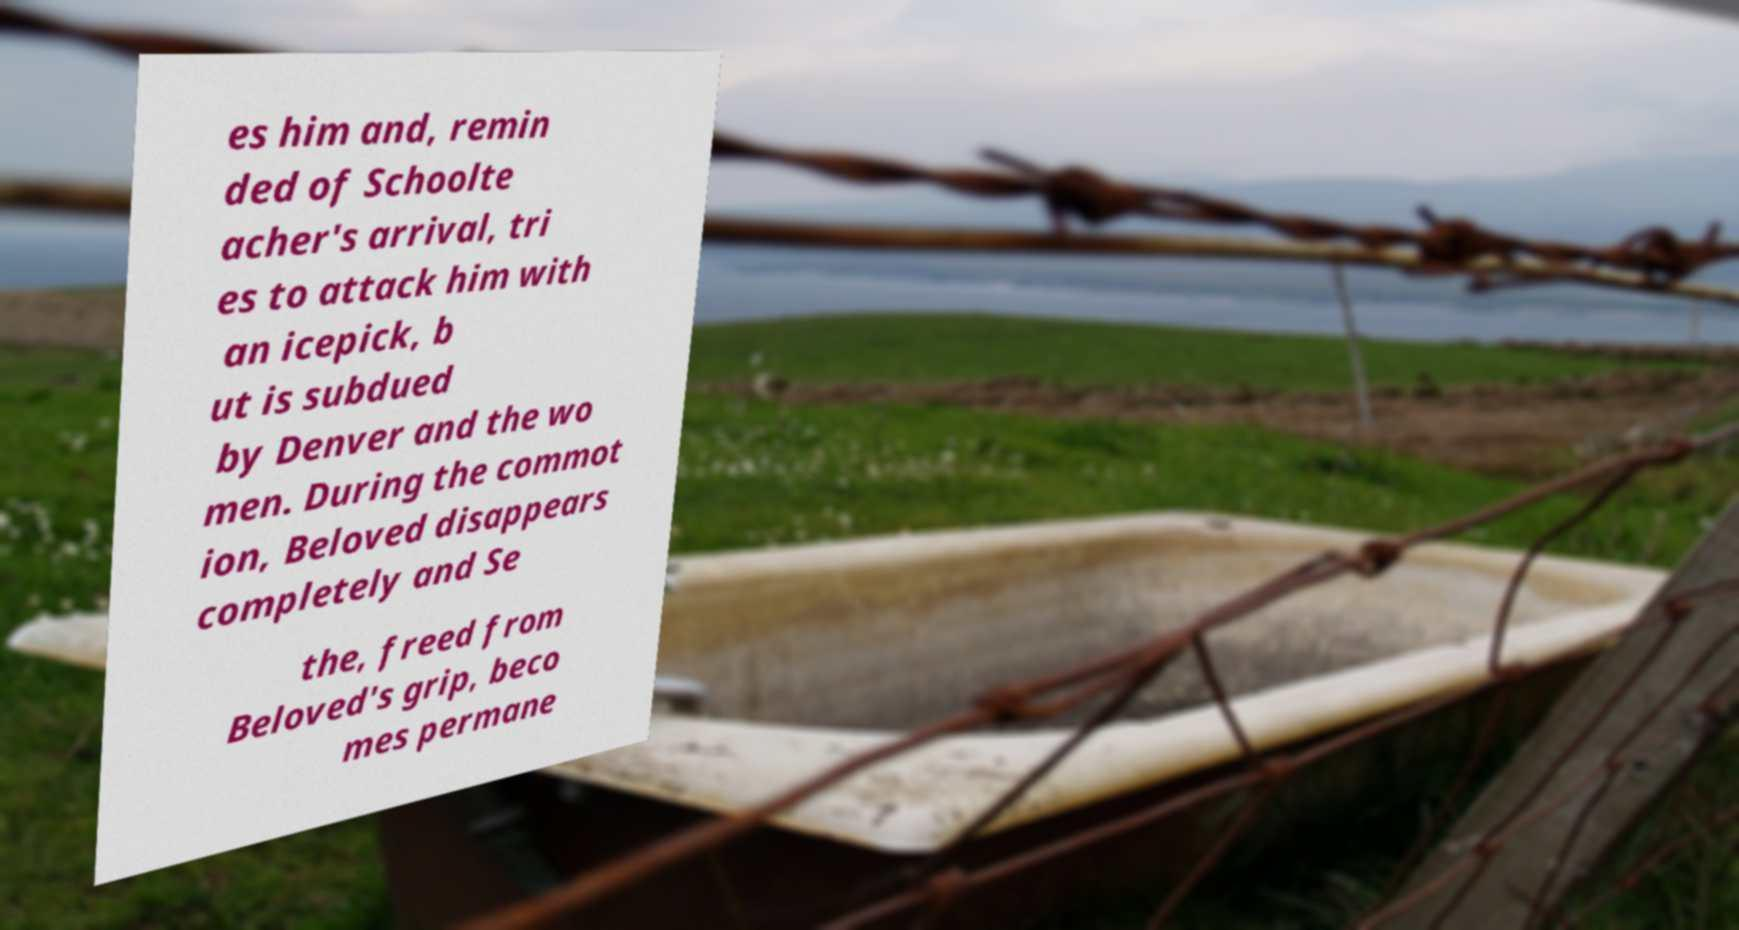Could you extract and type out the text from this image? es him and, remin ded of Schoolte acher's arrival, tri es to attack him with an icepick, b ut is subdued by Denver and the wo men. During the commot ion, Beloved disappears completely and Se the, freed from Beloved's grip, beco mes permane 